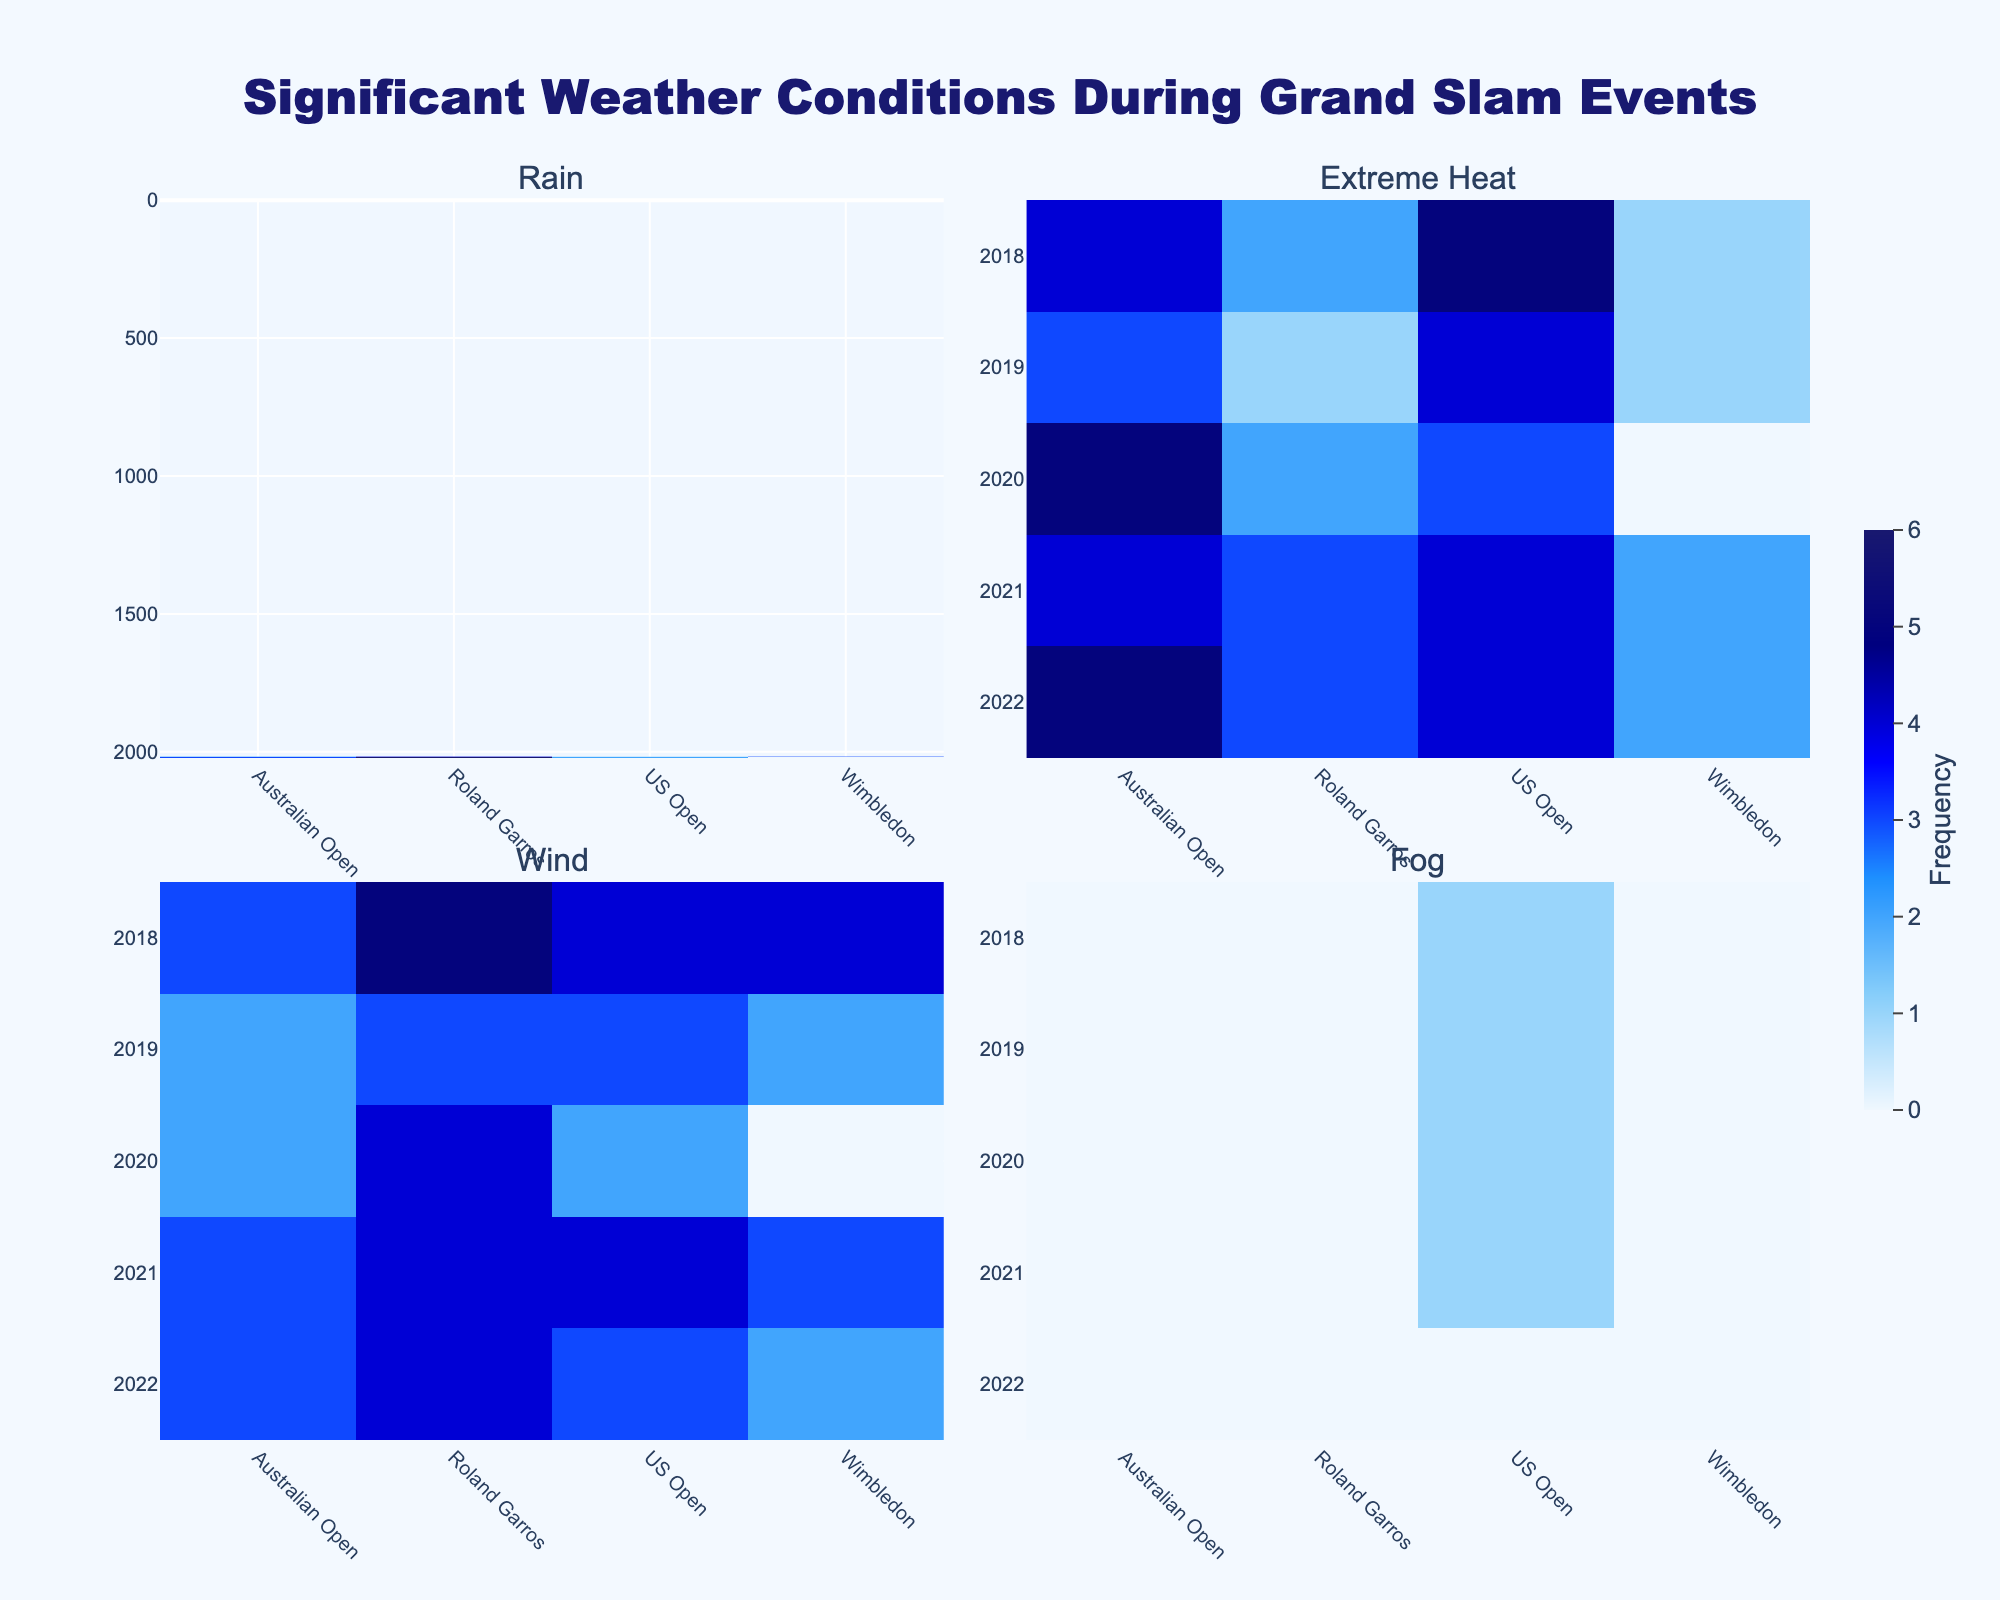What's the title of the figure? The title is displayed prominently at the top center of the figure. The text is made larger and bolder to stand out.
Answer: Significant Weather Conditions During Grand Slam Events Which event had the highest frequency of rain in 2020? Locate the 2020 row and navigate to the "Rain" subplot. Compare the values for the Australian Open, Roland Garros, Wimbledon, and US Open. The highest frequency is 6 for Roland Garros.
Answer: Roland Garros Which year had the most occurrences of extreme heat during the US Open? Go to the "Extreme Heat" subplot and examine the column for the US Open. Compare the values across different years. The highest value is 5 in 2018.
Answer: 2018 What is the average frequency of wind conditions reported during Wimbledon from 2018 to 2022? Find the "Wind" subplot and look for Wimbledon data across 2018, 2019, 2021, and 2022. Omit 2020 since Wimbledon was not held that year. The values are 4, 2, 3, and 2. Calculate (4 + 2 + 3 + 2) / 4 = 2.75.
Answer: 2.75 Which grand slam event had the most frequent fog conditions in 2018, and how many occurrences were reported? Examine the "Fog" subplot and locate the 2018 row. Compare the frequencies for the Australian Open, Roland Garros, Wimbledon, and US Open. Only the US Open has instances of fog with a value of 1.
Answer: US Open, 1 How does the frequency of rain in the Australian Open in 2019 compare to 2020? Check the "Rain" subplot and find the values for the Australian Open in 2019 and 2020. In 2019, the frequency is 1, while it is 3 in 2020. 3 is greater than 1, so the frequency increased in 2020.
Answer: It increased What is the maximum reported value for extreme heat among all events from 2018 to 2022? Check the "Extreme Heat" subplot for the maximum value across all events and years. The highest recorded value for extreme heat is 5.
Answer: 5 How many times did rain conditions occur at the US Open events from 2018 to 2022? Locate the "Rain" subplot and sum the rain frequencies for the US Open from 2018 to 2022. The values are 1, 2, 2, 3, and 1. Sum them up to get 9.
Answer: 9 